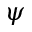<formula> <loc_0><loc_0><loc_500><loc_500>\psi</formula> 